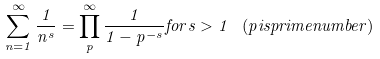<formula> <loc_0><loc_0><loc_500><loc_500>\sum _ { n = 1 } ^ { \infty } { \frac { 1 } { n ^ { s } } } = \prod _ { p } ^ { \infty } { \frac { 1 } { 1 - p ^ { - s } } } { f o r } s > 1 \, \ ( p { i s p r i m e n u m b e r ) }</formula> 